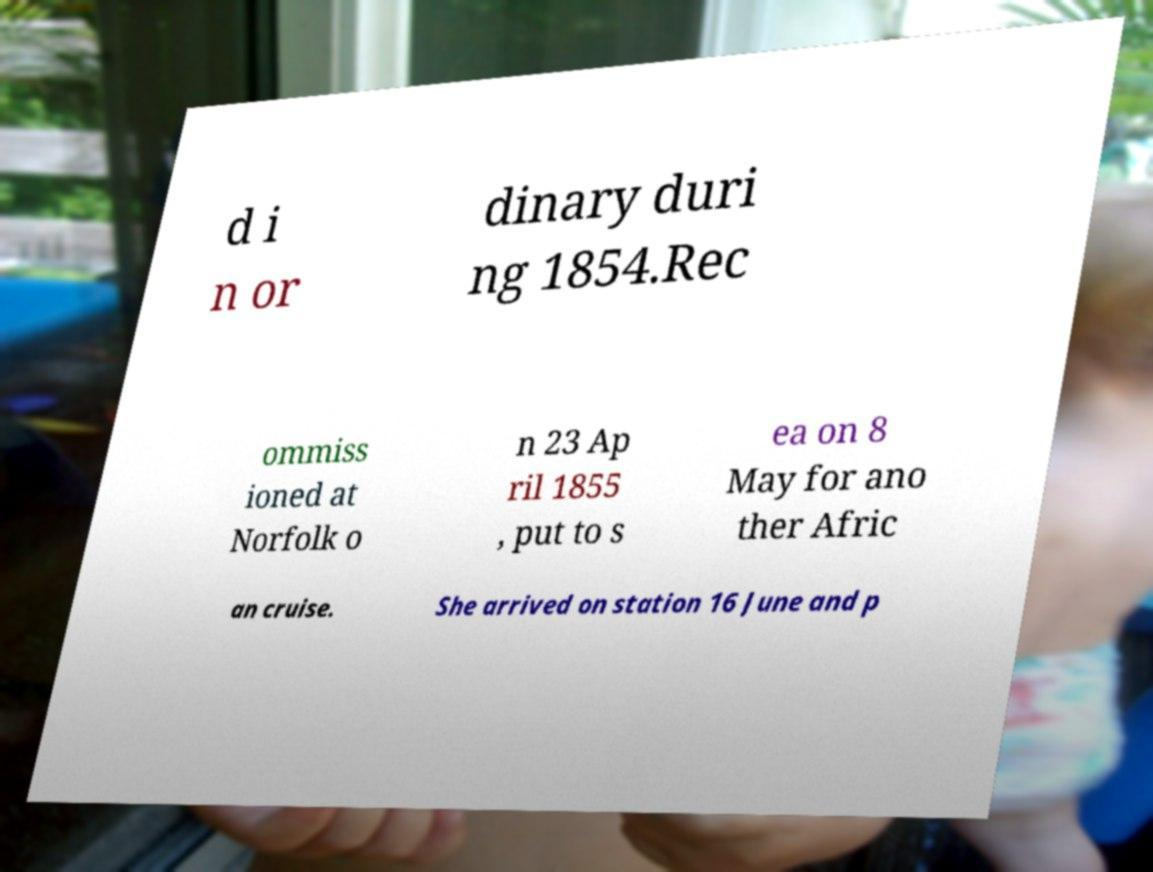Could you extract and type out the text from this image? d i n or dinary duri ng 1854.Rec ommiss ioned at Norfolk o n 23 Ap ril 1855 , put to s ea on 8 May for ano ther Afric an cruise. She arrived on station 16 June and p 